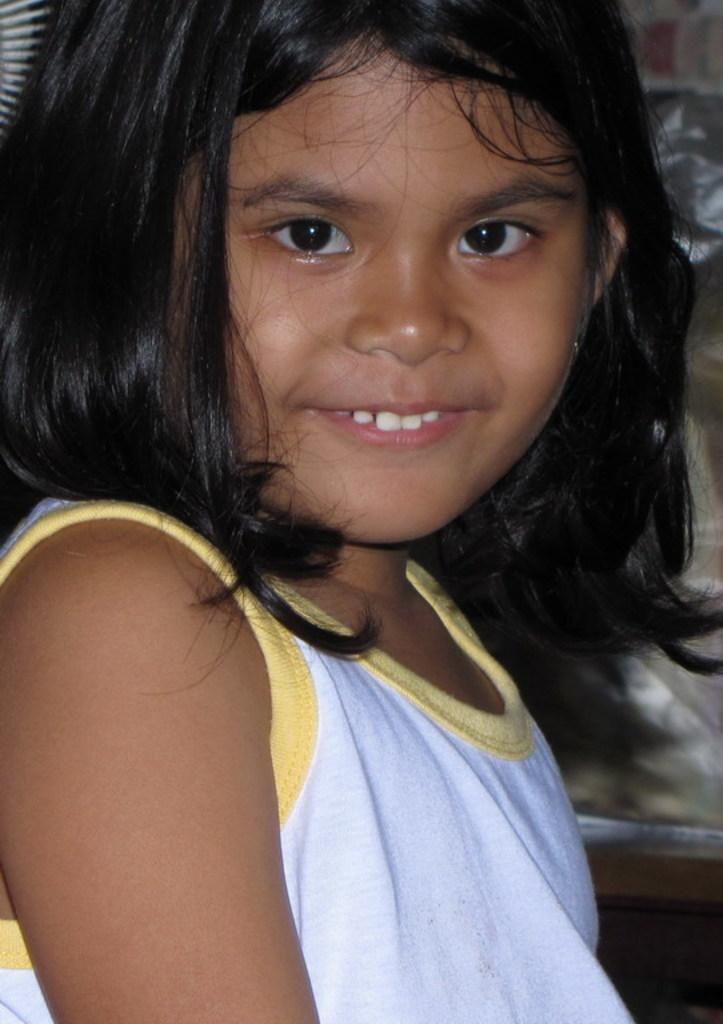What is the main subject of the image? There is a beautiful girl in the image. What is the girl's expression in the image? The girl is smiling in the image. What is the girl wearing in the image? The girl is wearing a white top in the image. What thing is the girl blowing in the image? There is no indication in the image that the girl is blowing anything. 